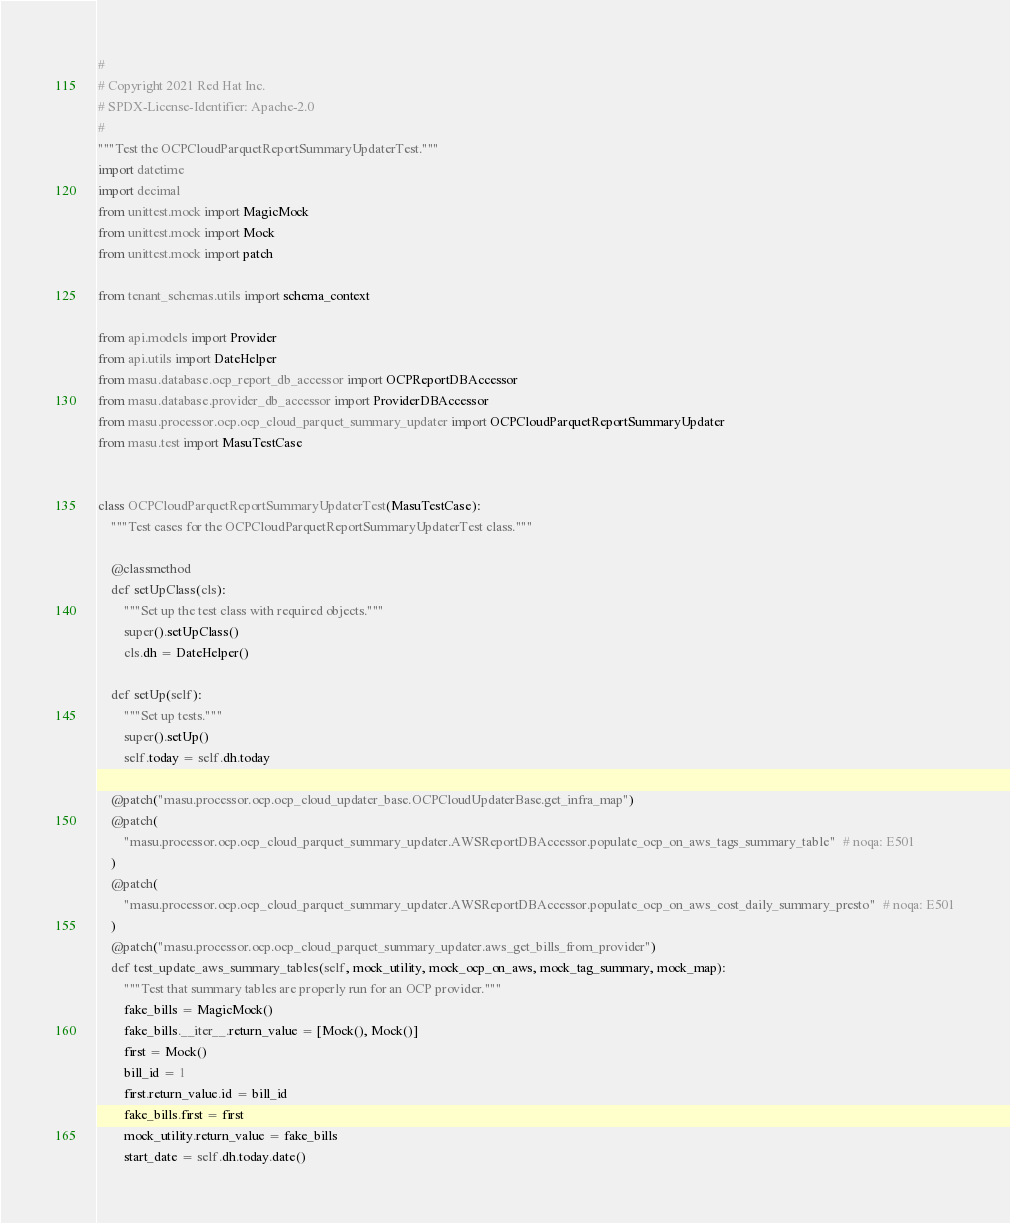<code> <loc_0><loc_0><loc_500><loc_500><_Python_>#
# Copyright 2021 Red Hat Inc.
# SPDX-License-Identifier: Apache-2.0
#
"""Test the OCPCloudParquetReportSummaryUpdaterTest."""
import datetime
import decimal
from unittest.mock import MagicMock
from unittest.mock import Mock
from unittest.mock import patch

from tenant_schemas.utils import schema_context

from api.models import Provider
from api.utils import DateHelper
from masu.database.ocp_report_db_accessor import OCPReportDBAccessor
from masu.database.provider_db_accessor import ProviderDBAccessor
from masu.processor.ocp.ocp_cloud_parquet_summary_updater import OCPCloudParquetReportSummaryUpdater
from masu.test import MasuTestCase


class OCPCloudParquetReportSummaryUpdaterTest(MasuTestCase):
    """Test cases for the OCPCloudParquetReportSummaryUpdaterTest class."""

    @classmethod
    def setUpClass(cls):
        """Set up the test class with required objects."""
        super().setUpClass()
        cls.dh = DateHelper()

    def setUp(self):
        """Set up tests."""
        super().setUp()
        self.today = self.dh.today

    @patch("masu.processor.ocp.ocp_cloud_updater_base.OCPCloudUpdaterBase.get_infra_map")
    @patch(
        "masu.processor.ocp.ocp_cloud_parquet_summary_updater.AWSReportDBAccessor.populate_ocp_on_aws_tags_summary_table"  # noqa: E501
    )
    @patch(
        "masu.processor.ocp.ocp_cloud_parquet_summary_updater.AWSReportDBAccessor.populate_ocp_on_aws_cost_daily_summary_presto"  # noqa: E501
    )
    @patch("masu.processor.ocp.ocp_cloud_parquet_summary_updater.aws_get_bills_from_provider")
    def test_update_aws_summary_tables(self, mock_utility, mock_ocp_on_aws, mock_tag_summary, mock_map):
        """Test that summary tables are properly run for an OCP provider."""
        fake_bills = MagicMock()
        fake_bills.__iter__.return_value = [Mock(), Mock()]
        first = Mock()
        bill_id = 1
        first.return_value.id = bill_id
        fake_bills.first = first
        mock_utility.return_value = fake_bills
        start_date = self.dh.today.date()</code> 